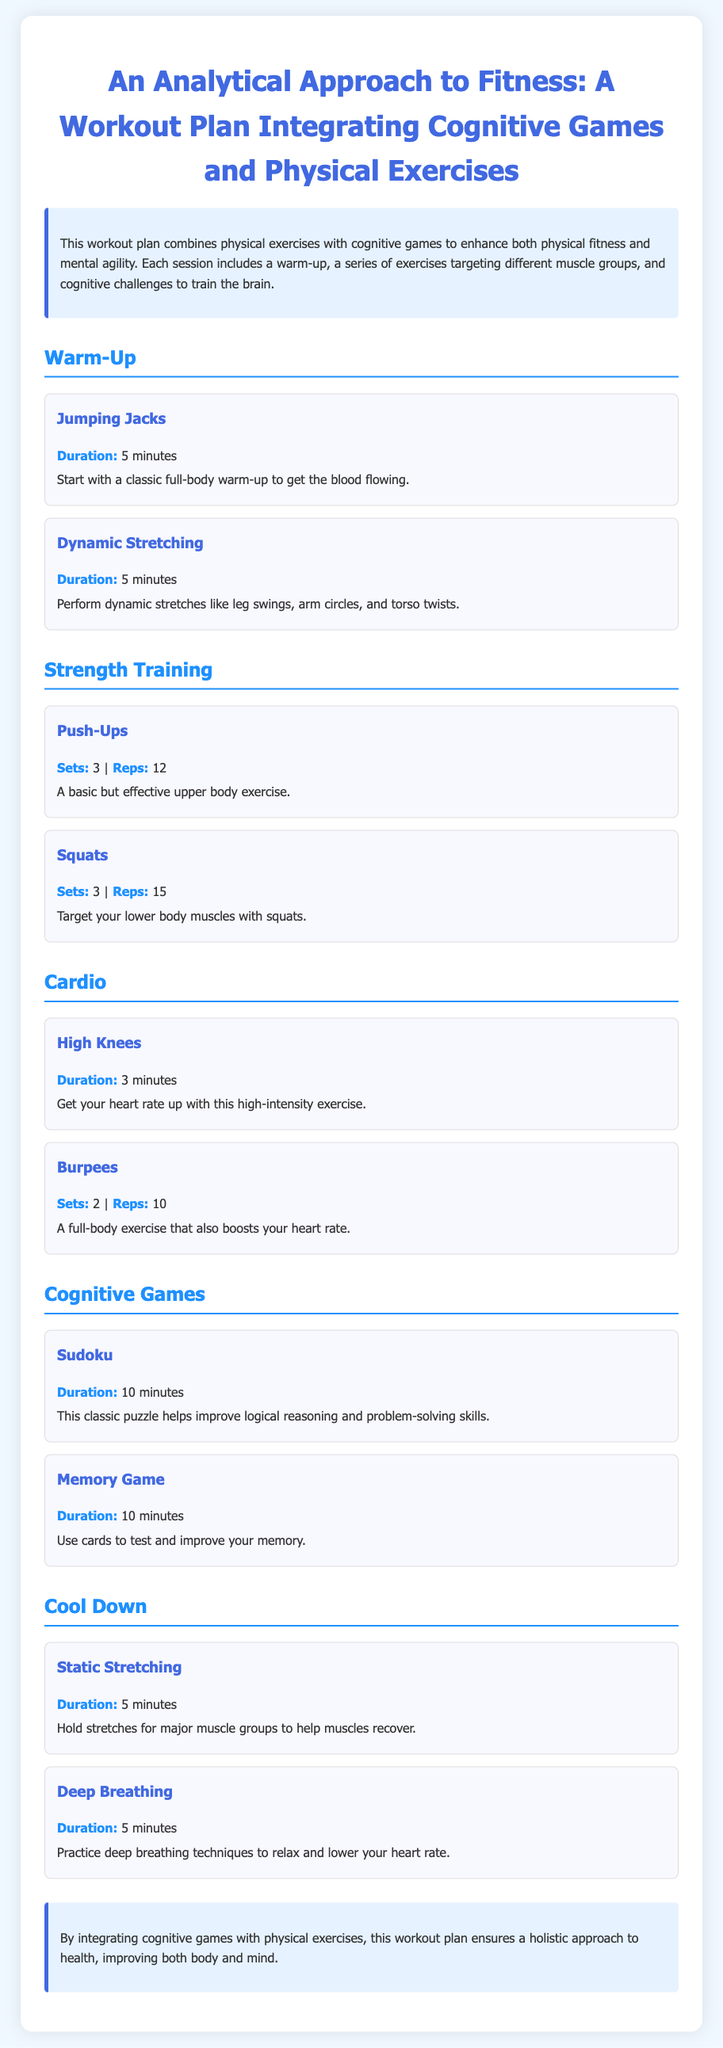What is the duration of the warm-up? The warm-up consists of 5 minutes for Jumping Jacks and 5 minutes for Dynamic Stretching, totaling 10 minutes.
Answer: 10 minutes How many sets of Push-Ups are recommended? The document specifies 3 sets of Push-Ups in the Strength Training section.
Answer: 3 What cognitive game takes 10 minutes to complete? Sudoku is mentioned as a cognitive game that requires 10 minutes.
Answer: Sudoku What is the duration for Static Stretching in the Cool Down section? The document states the duration for Static Stretching is 5 minutes.
Answer: 5 minutes What is the total number of exercises listed under Strength Training? There are two exercises listed: Push-Ups and Squats, totaling 2.
Answer: 2 Which exercise is classified as a high-intensity cardio workout? High Knees is identified as a high-intensity cardio exercise in the document.
Answer: High Knees What type of stretching is done during the Cool Down phase? The Cool Down phase mentions doing Static Stretching.
Answer: Static Stretching What is the purpose of integrating cognitive games with physical exercises? The integration aims to ensure a holistic approach to health, improving both body and mind.
Answer: Holistic approach to health How many reps are recommended for Squats? The document specifies 15 reps for Squats.
Answer: 15 